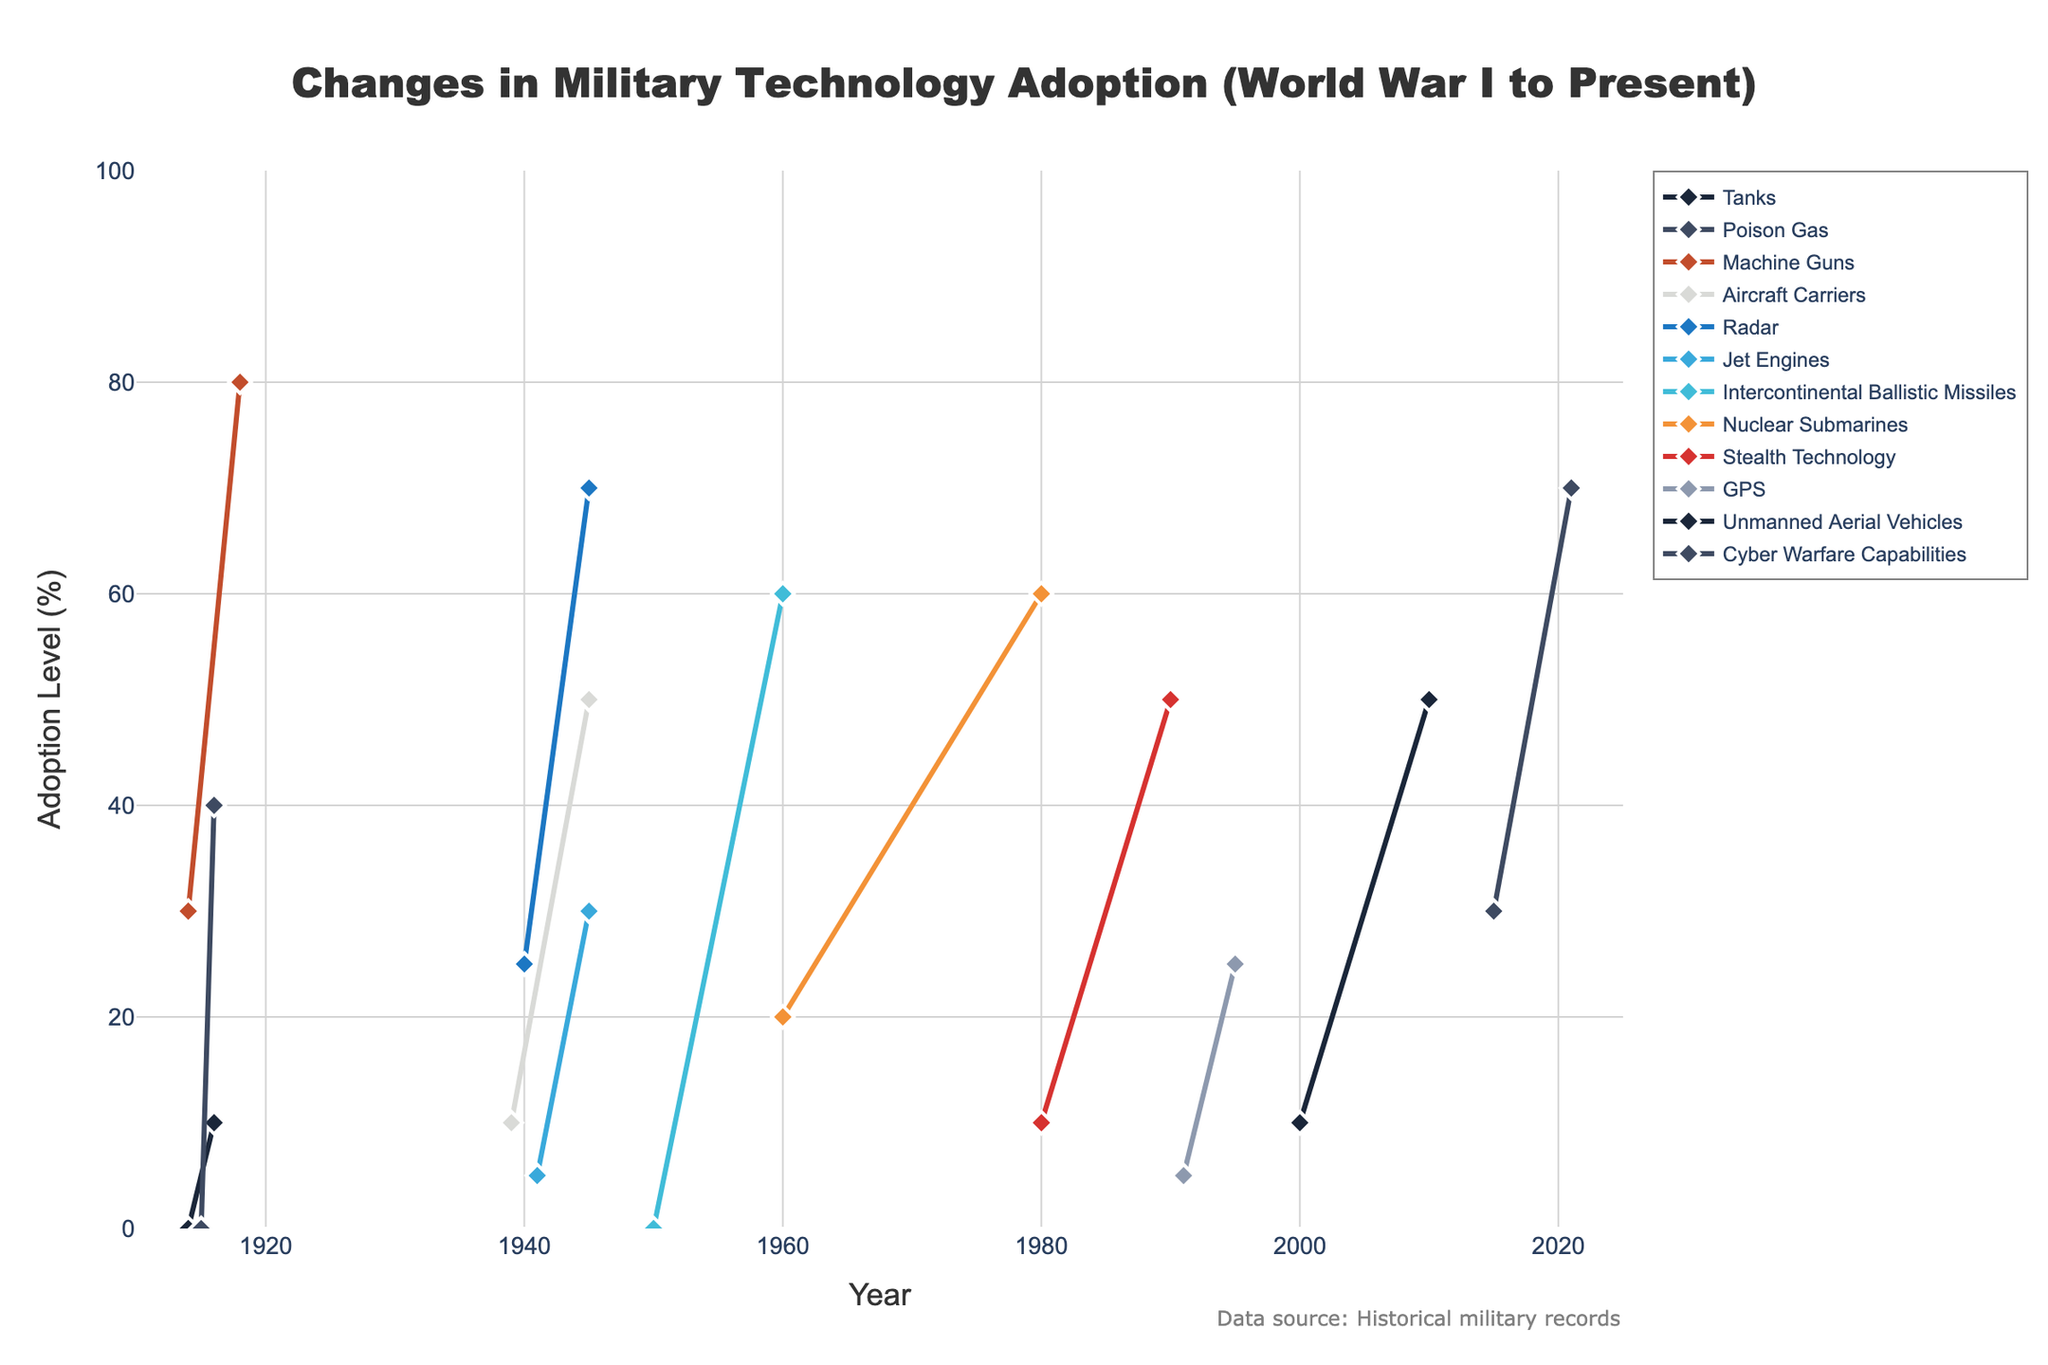When does the plot show the first adoption of tanks? Referring to the plot, the first adoption of tanks is shown starting at a level of 0 in 1914 and rising to 10 by 1916.
Answer: 1914 Which technology saw the most significant increase from World War I to World War II? By observing the adoption levels, radar increased from 25% in 1940 to 70% in 1945, showing the largest gain compared to other technologies within this timeframe.
Answer: Radar How does the adoption level of GPS in 1995 compare to unmanned aerial vehicles in 2000? The figure shows GPS at an adoption level of 25 in 1995 and unmanned aerial vehicles at 10 in 2000. Thus, GPS had a higher adoption level than unmanned aerial vehicles at these time points.
Answer: GPS has a higher adoption level Which technologies reached the highest adoption level by 2021? The plot indicates that cyber warfare capabilities reached an adoption level of 70% by 2021. This is the highest adoption level among all technologies by that year.
Answer: Cyber warfare capabilities What is the difference in adoption level of intercontinental ballistic missiles between 1950 and 1960? Intercontinental ballistic missiles had an adoption level of 0 in 1950 and reached 60 in 1960. The difference is 60 - 0 = 60.
Answer: 60 How many technologies were first adopted during World War II (1939-1945)? During World War II, the technologies first adopted are Aircraft Carriers, Radar, and Jet Engines.
Answer: 3 What is the slope of the adoption curve for stealth technology between 1980 and 1990? The adoption level for stealth technology rises from 10 in 1980 to 50 in 1990. So the slope (change in adoption level/change in years) is (50 - 10) / (1990 - 1980) = 40 / 10 = 4.
Answer: 4 Compare the adoption levels of machine guns in 1918 and cyber warfare capabilities in 2021. Which is higher? Machine guns had an adoption level of 80 in 1918, whereas cyber warfare capabilities reached 70 in 2021. Thus, machine guns had a higher adoption level.
Answer: Machine guns What is the average adoption level of tanks, poison gas, and machine guns in their latest recorded years? Tanks reach 10 in 1916, poison gas reaches 40 in 1916, and machine guns reach 80 in 1918. The average adoption level is (10 + 40 + 80)/3 = 130/3 ≈ 43.33.
Answer: 43.33 How many years did it take for unmanned aerial vehicles to reach an adoption level of 50? Unmanned aerial vehicles started at 10 in 2000 and reached 50 in 2010, which took 10 years.
Answer: 10 